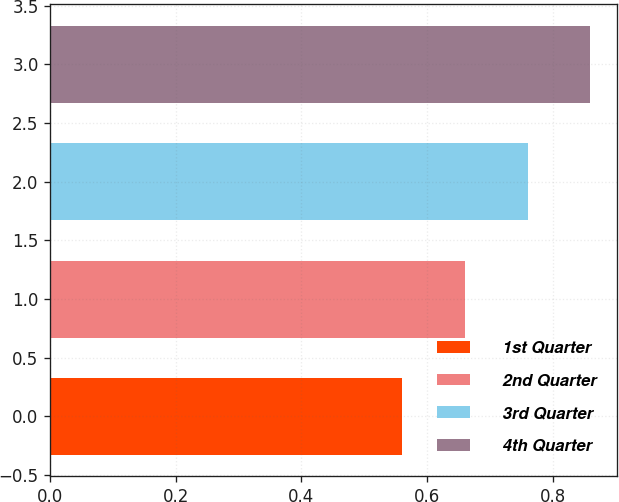Convert chart to OTSL. <chart><loc_0><loc_0><loc_500><loc_500><bar_chart><fcel>1st Quarter<fcel>2nd Quarter<fcel>3rd Quarter<fcel>4th Quarter<nl><fcel>0.56<fcel>0.66<fcel>0.76<fcel>0.86<nl></chart> 